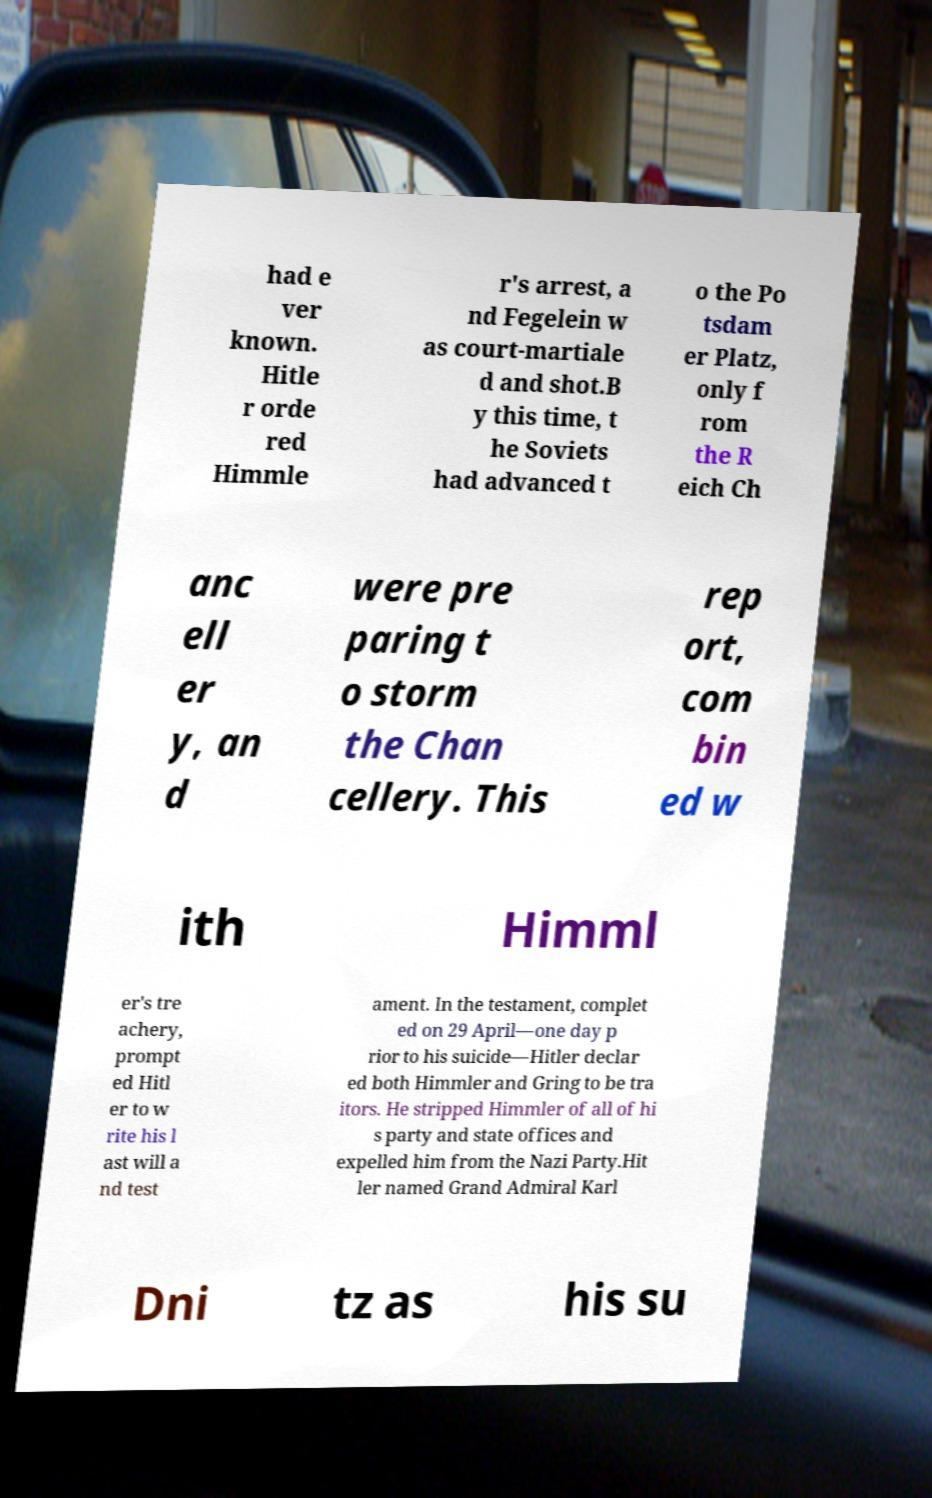Please identify and transcribe the text found in this image. had e ver known. Hitle r orde red Himmle r's arrest, a nd Fegelein w as court-martiale d and shot.B y this time, t he Soviets had advanced t o the Po tsdam er Platz, only f rom the R eich Ch anc ell er y, an d were pre paring t o storm the Chan cellery. This rep ort, com bin ed w ith Himml er's tre achery, prompt ed Hitl er to w rite his l ast will a nd test ament. In the testament, complet ed on 29 April—one day p rior to his suicide—Hitler declar ed both Himmler and Gring to be tra itors. He stripped Himmler of all of hi s party and state offices and expelled him from the Nazi Party.Hit ler named Grand Admiral Karl Dni tz as his su 